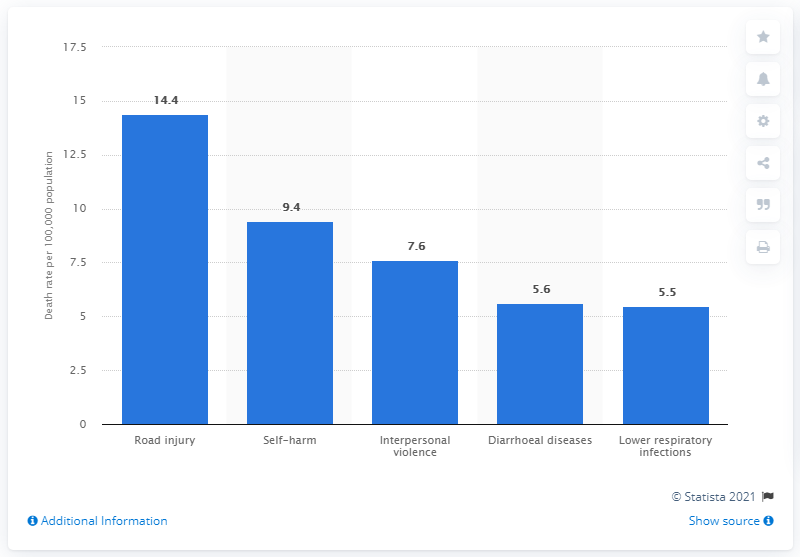List a handful of essential elements in this visual. In 2015, the death rate for road injuries among adolescents aged 15 to 19 years was 14.4 per 100,000 people. 